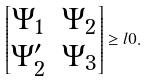Convert formula to latex. <formula><loc_0><loc_0><loc_500><loc_500>\left [ \begin{matrix} \Psi _ { 1 } & \Psi _ { 2 } \\ \Psi _ { 2 } ^ { \prime } & \Psi _ { 3 } \end{matrix} \right ] \geq l 0 .</formula> 